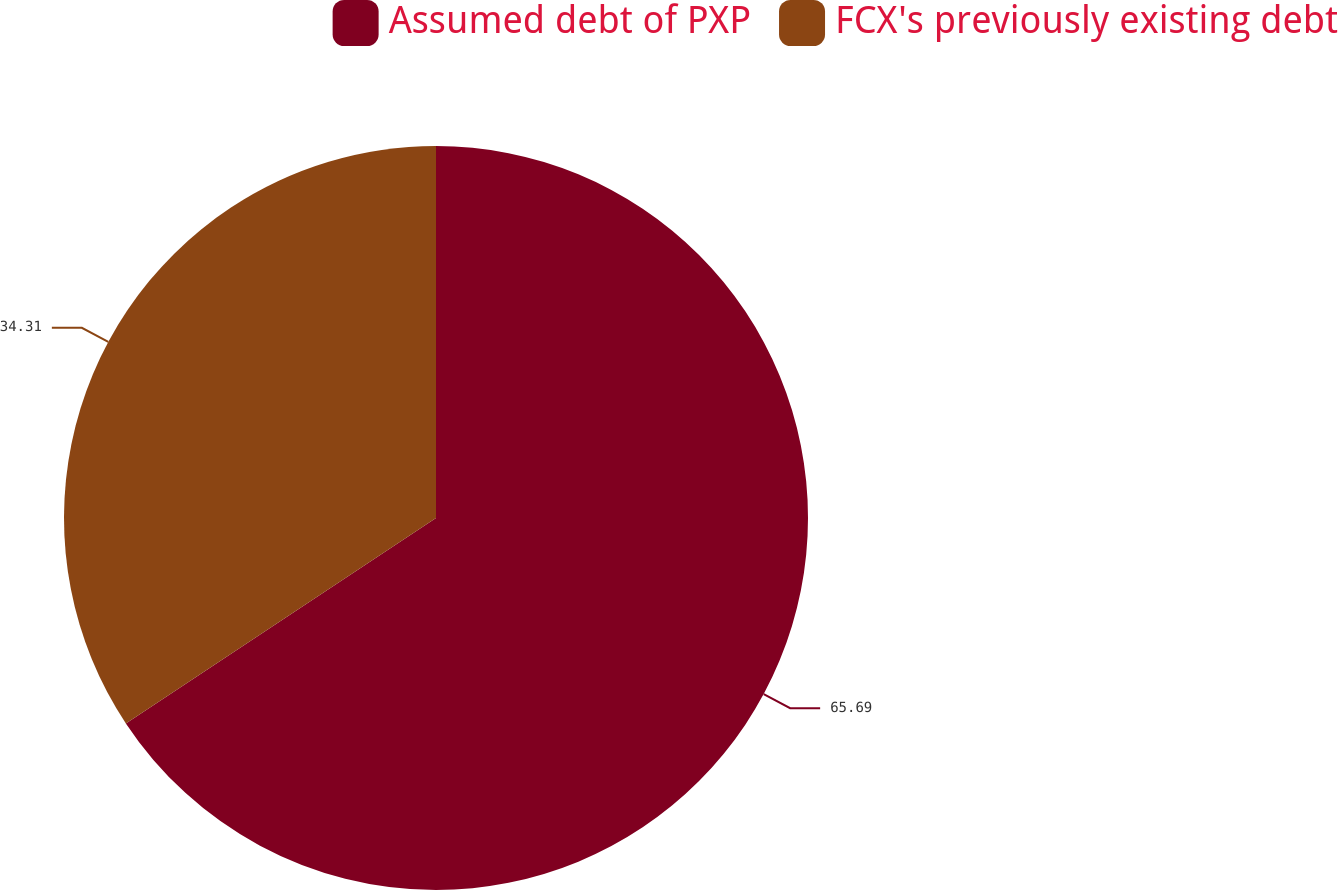Convert chart to OTSL. <chart><loc_0><loc_0><loc_500><loc_500><pie_chart><fcel>Assumed debt of PXP<fcel>FCX's previously existing debt<nl><fcel>65.69%<fcel>34.31%<nl></chart> 